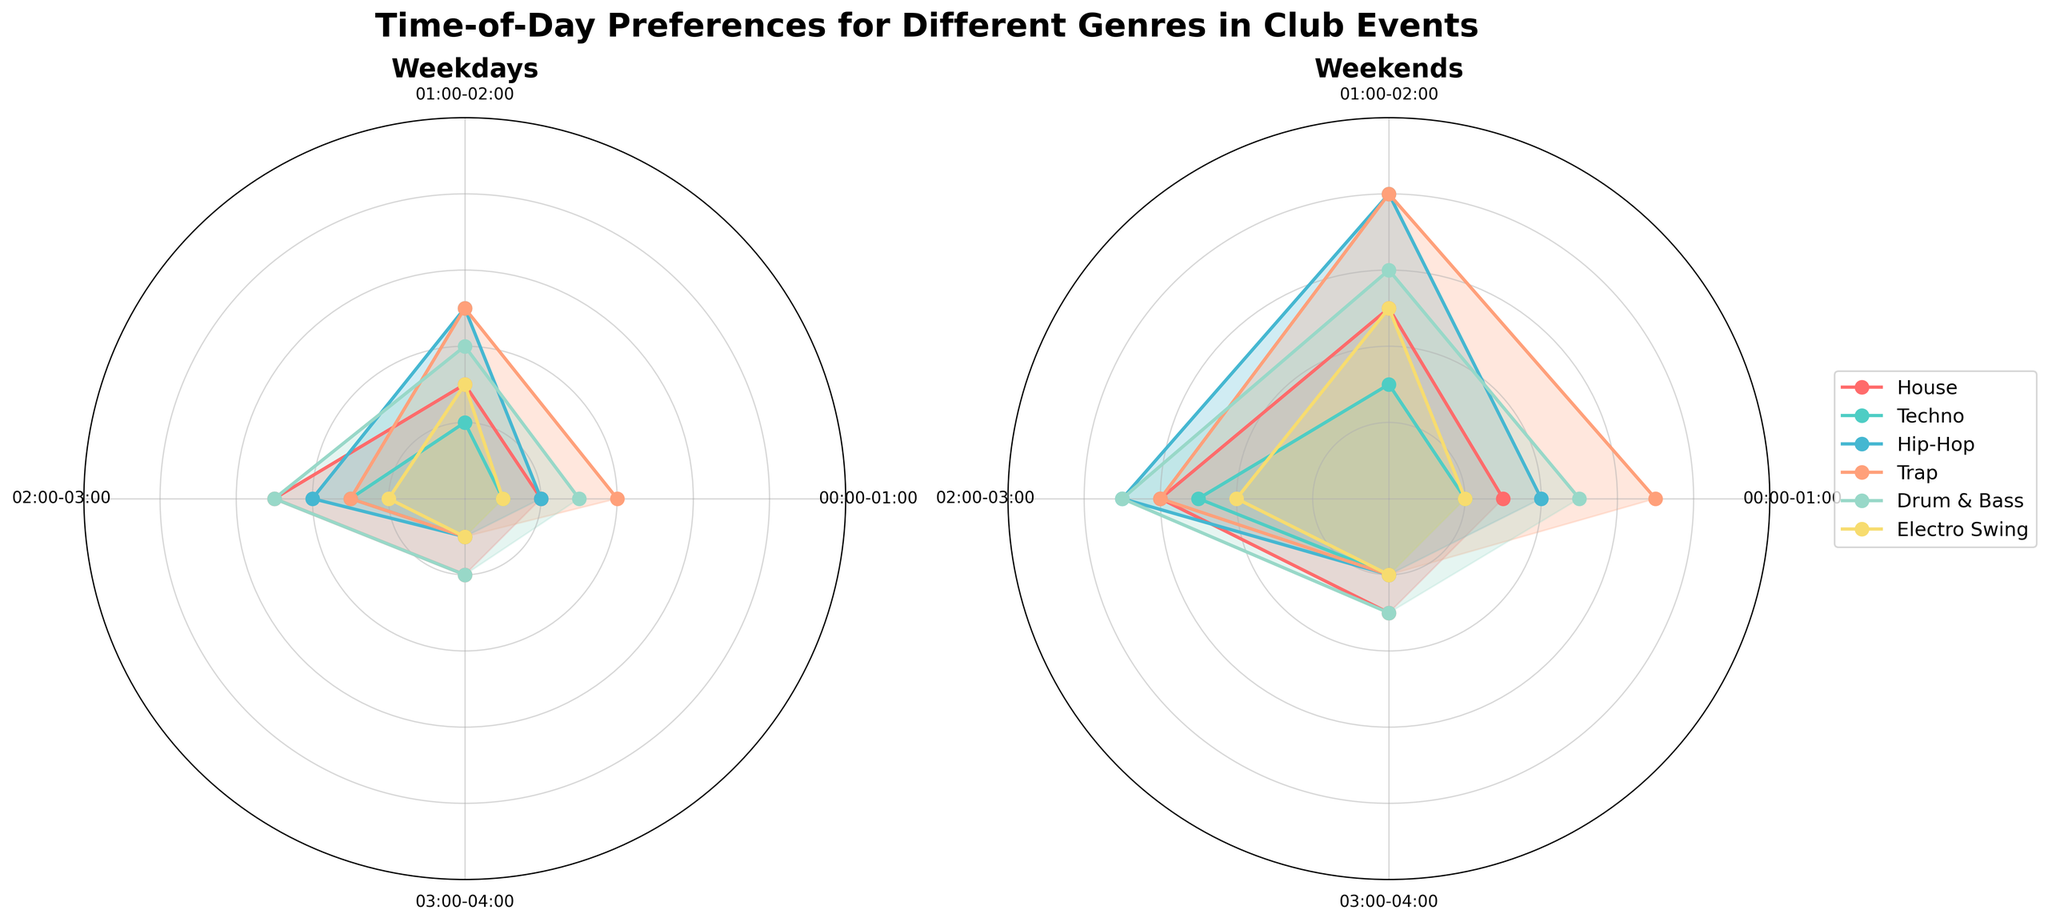What is the title of the figure? The title is usually found at the top of the figure. In this case, it states, "Time-of-Day Preferences for Different Genres in Club Events".
Answer: "Time-of-Day Preferences for Different Genres in Club Events" What are the two main sections of the figure? The figure is clearly divided into two sections, each titled. The left plot is titled "Weekdays" and the right plot is titled "Weekends".
Answer: Weekdays and Weekends Which genre has the highest preference at 01:00-02:00 on weekends? To determine this, look at the height of each genre's plot at the 01:00-02:00 time slot in the Weekend section. The highest value is for House.
Answer: House How does the preference for Techno at 03:00-04:00 compare on weekdays and weekends? For this, compare the lengths of the plot lines in the "Techno" segment for the 03:00-04:00 time slot in both the Weekday and Weekend sections. On weekdays, it reaches 10, while on weekends, it reaches 15.
Answer: It is higher on weekends Which genre has the least preference at 00:00-01:00 on weekdays? Check the length of plot lines for each genre at the 00:00-01:00 time slot in the Weekday section. The shortest line corresponds to Trap and Electro Swing.
Answer: Trap and Electro Swing During which time slot do Hip-Hop and House have the same preference on weekdays? Compare the plots for Hip-Hop and House for each time segment in the Weekday section and find where the lines intersect in length. Both genres have a value of 25 at 01:00-02:00.
Answer: 01:00-02:00 What is the average preference for Drum & Bass from 00:00-01:00 to 03:00-04:00 on weekends? Add the preference values for Drum & Bass at each time slot on weekends (15 + 25 + 30 + 15 = 85) and divide by the number of time slots (4).
Answer: 21.25 Compare the change in preferences for House between 00:00-01:00 and 01:00-02:00 on weekdays with the change on weekends. Calculate the difference for weekdays (25 - 20 = 5) and weekends (40 - 35 = 5). Both differences are equal.
Answer: They have the same change Which genre consistently shows the least variation in preference across all time slots on weekdays? Examine the consistency of the line lengths for each genre across all time slots in the Weekday section. Electro Swing shows the least variation.
Answer: Electro Swing 